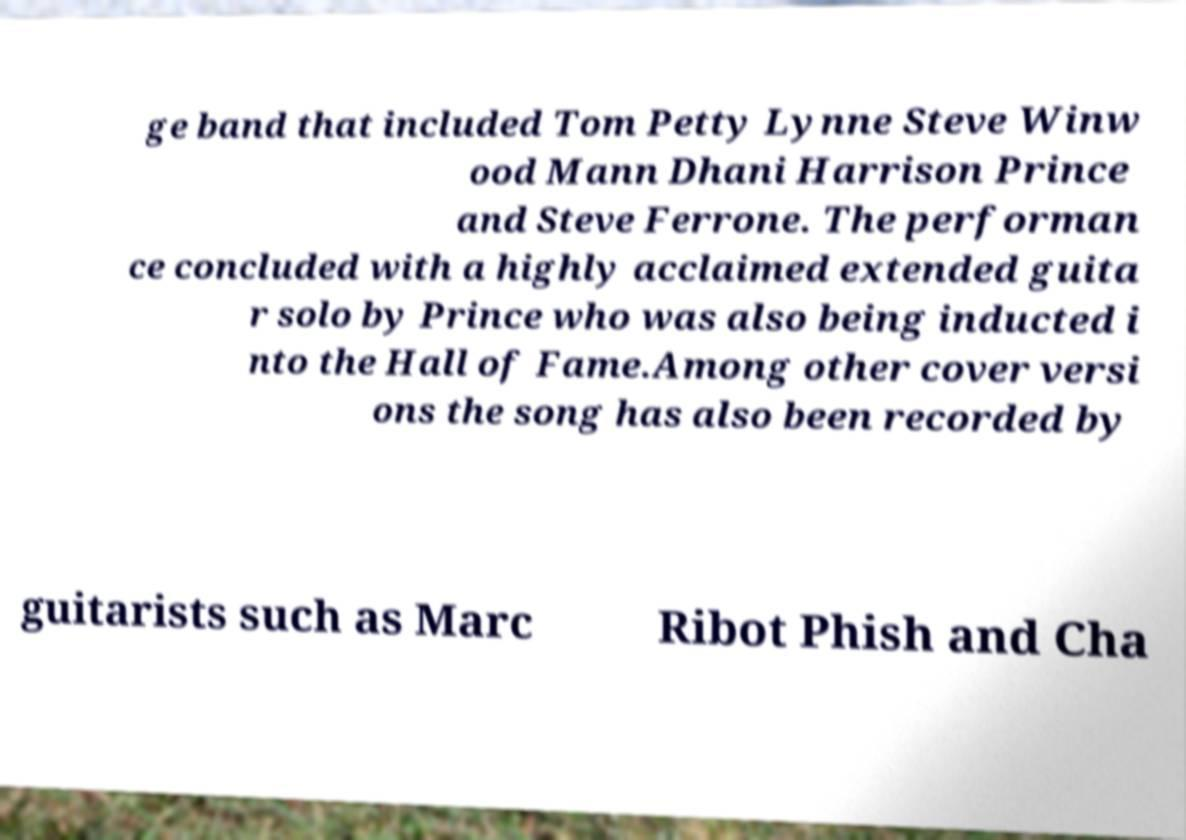Could you extract and type out the text from this image? ge band that included Tom Petty Lynne Steve Winw ood Mann Dhani Harrison Prince and Steve Ferrone. The performan ce concluded with a highly acclaimed extended guita r solo by Prince who was also being inducted i nto the Hall of Fame.Among other cover versi ons the song has also been recorded by guitarists such as Marc Ribot Phish and Cha 